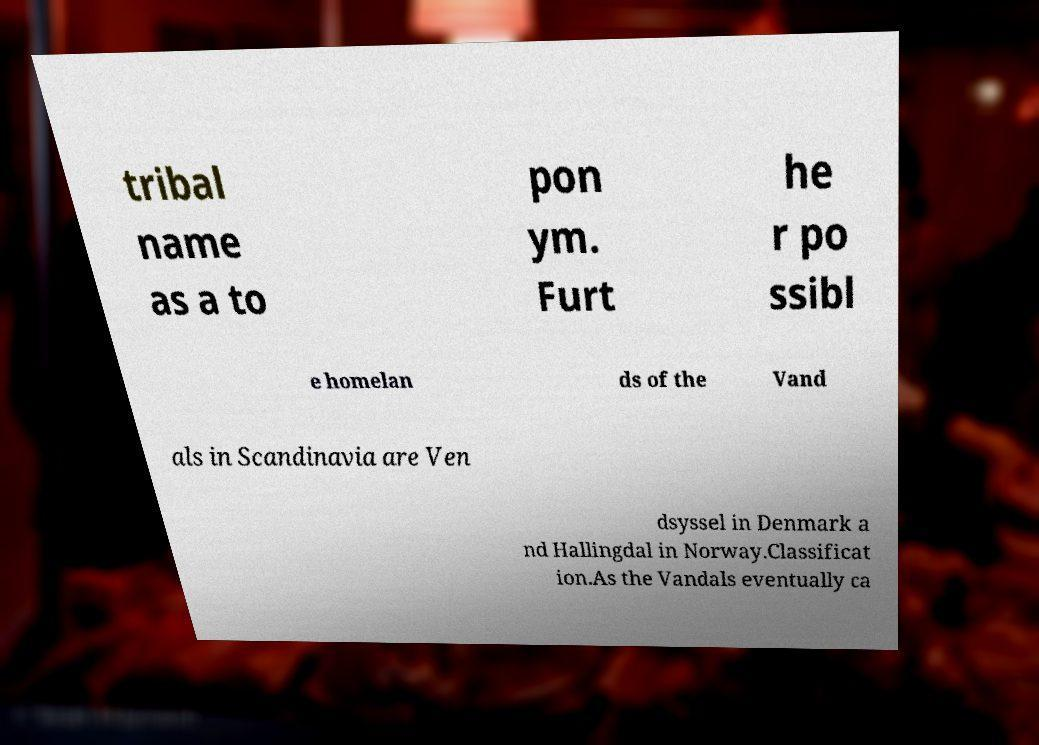Can you read and provide the text displayed in the image?This photo seems to have some interesting text. Can you extract and type it out for me? tribal name as a to pon ym. Furt he r po ssibl e homelan ds of the Vand als in Scandinavia are Ven dsyssel in Denmark a nd Hallingdal in Norway.Classificat ion.As the Vandals eventually ca 